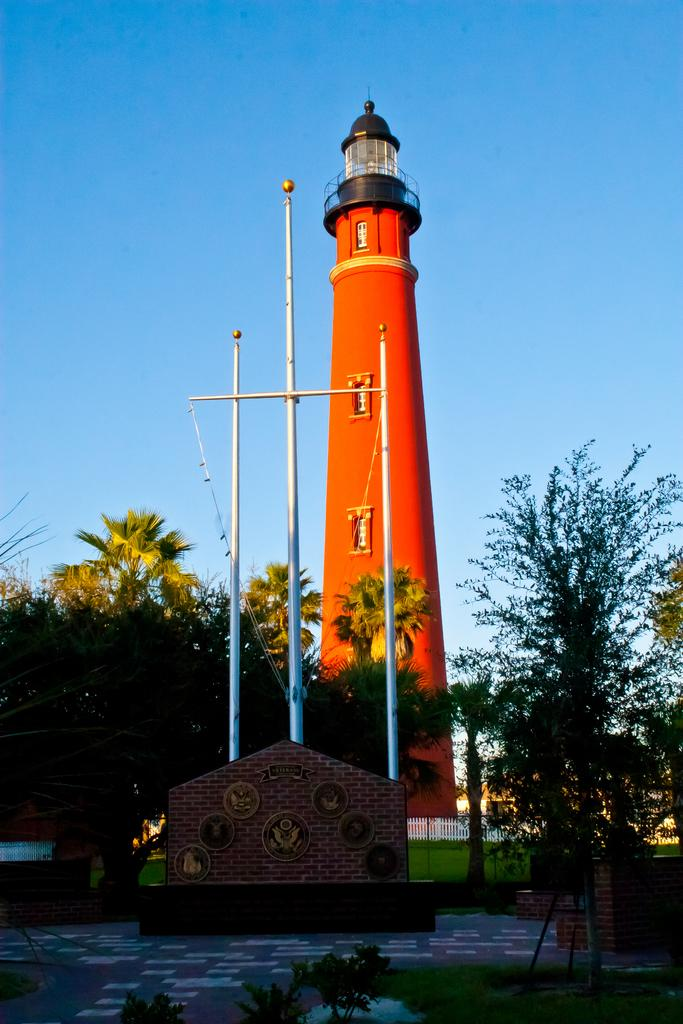What is the main structure in the image? There is a lighthouse in the image. What type of vegetation can be seen in the image? There are trees, grass, and plants in the image. What type of barrier is present in the image? There is a fence in the image. What type of surface is visible in the image? There is a path in the image. What type of construction material is used for the wall in the image? There is a brick wall in the image. What is visible in the background of the image? There is sky visible in the image. How many degrees of heat can be felt from the loaf in the image? There is no loaf present in the image, so it is not possible to determine the temperature or degree of heat. 